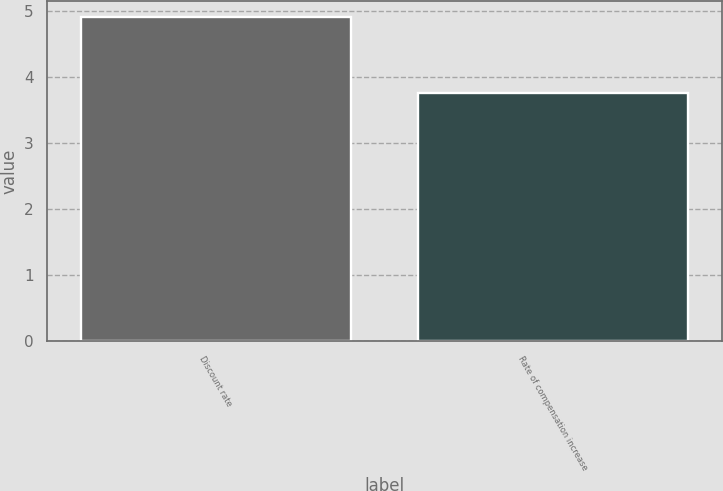Convert chart. <chart><loc_0><loc_0><loc_500><loc_500><bar_chart><fcel>Discount rate<fcel>Rate of compensation increase<nl><fcel>4.9<fcel>3.75<nl></chart> 